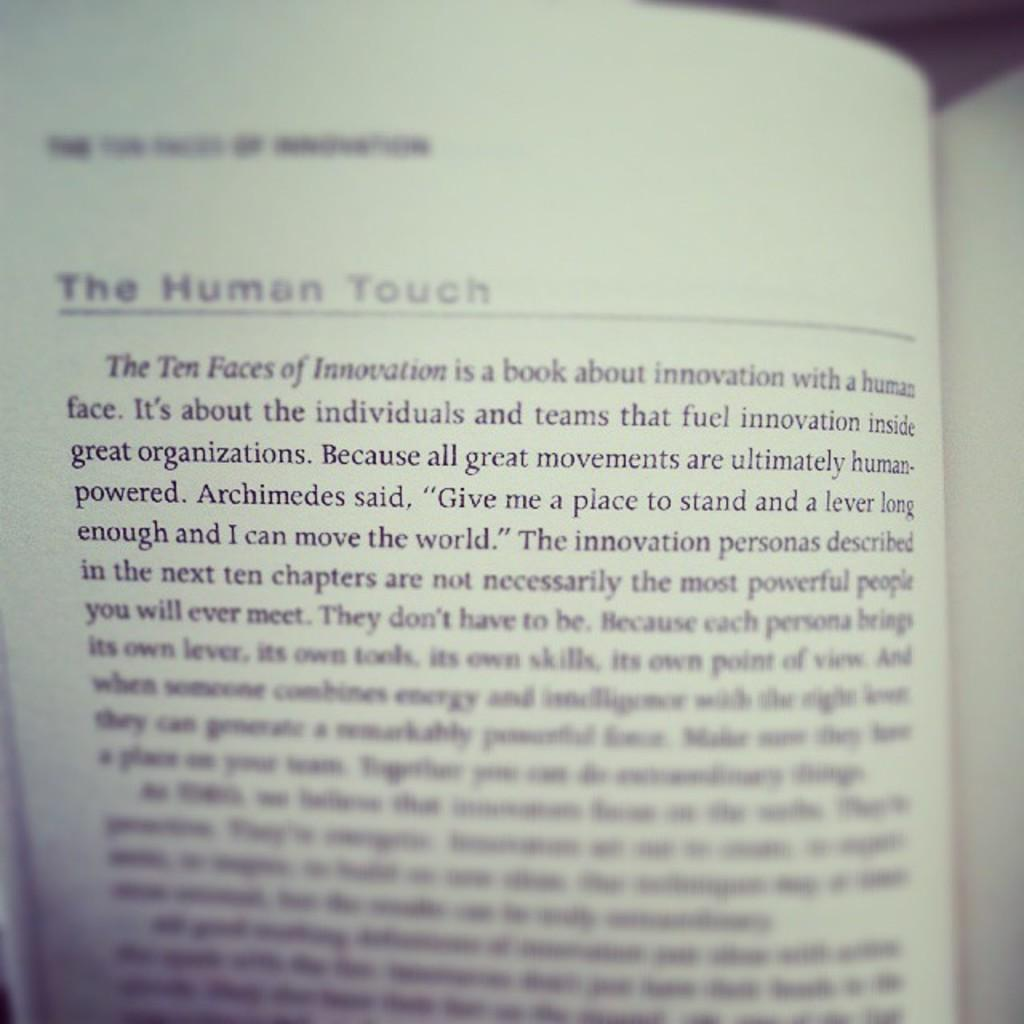Provide a one-sentence caption for the provided image. open book and on the left page it has The Human Touch underlined near the top. 